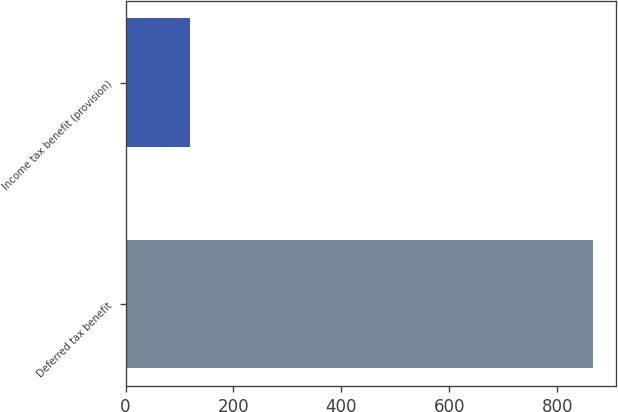<chart> <loc_0><loc_0><loc_500><loc_500><bar_chart><fcel>Deferred tax benefit<fcel>Income tax benefit (provision)<nl><fcel>866<fcel>119<nl></chart> 